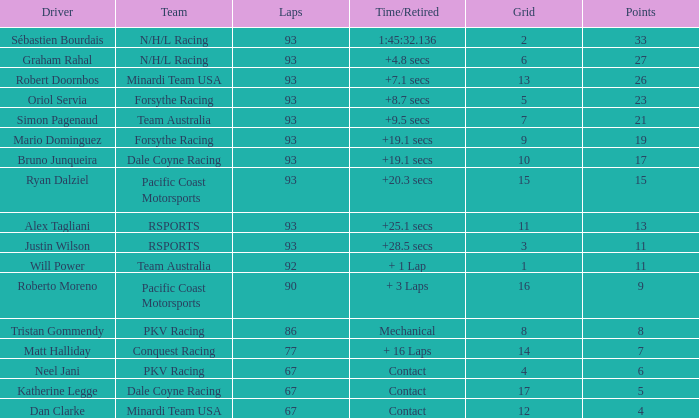What is the grid for the Minardi Team USA with laps smaller than 90? 12.0. 